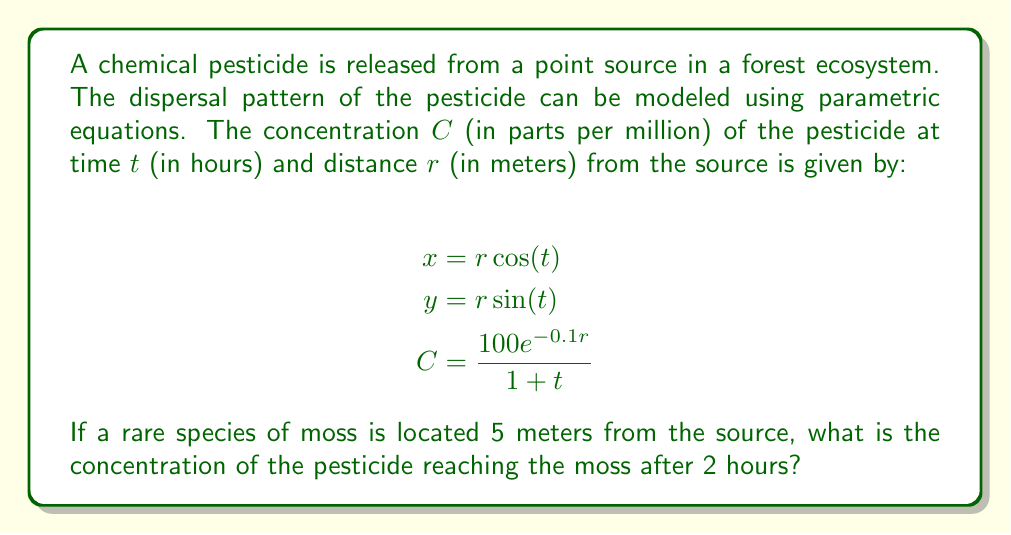Give your solution to this math problem. To solve this problem, we need to follow these steps:

1) We are given the parametric equations for the dispersal pattern:
   $$x = r \cos(t)$$
   $$y = r \sin(t)$$
   $$C = \frac{100e^{-0.1r}}{1 + t}$$

2) We are asked about the concentration at a specific point and time:
   - Distance from source, $r = 5$ meters
   - Time, $t = 2$ hours

3) We don't need to use the $x$ and $y$ equations in this case, as we're given the distance $r$ directly.

4) We can plug these values into the concentration equation:

   $$C = \frac{100e^{-0.1(5)}}{1 + 2}$$

5) Let's solve this step by step:
   - First, calculate $e^{-0.1(5)} = e^{-0.5} \approx 0.6065$
   - Then, $100 * 0.6065 = 60.65$
   - In the denominator, $1 + 2 = 3$

   So we have: $$C = \frac{60.65}{3}$$

6) Dividing: $$C \approx 20.22$$

Therefore, the concentration of the pesticide reaching the moss after 2 hours is approximately 20.22 parts per million.
Answer: $20.22$ parts per million 